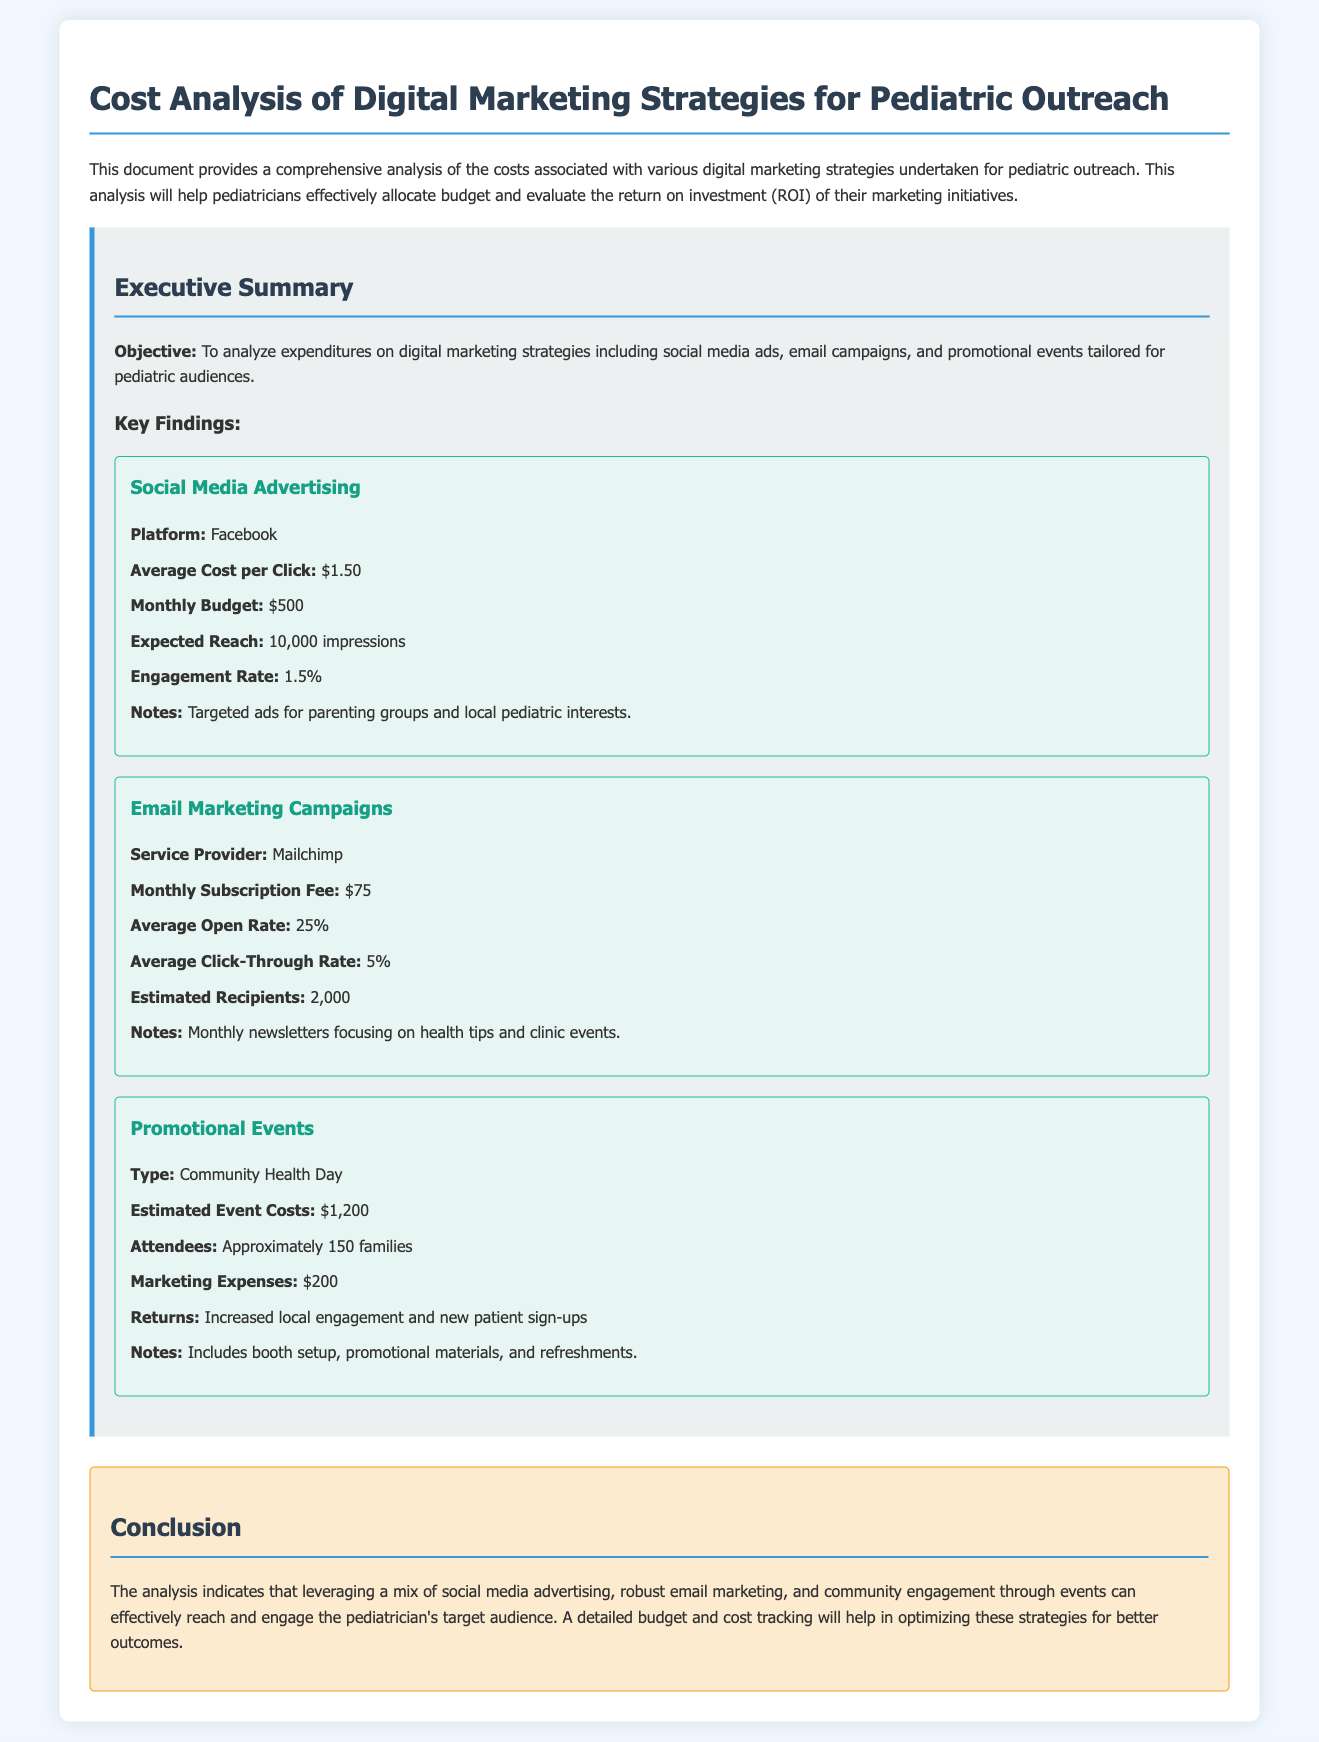What is the average cost per click for social media ads? The average cost per click for social media ads is stated directly under the social media advertising section in the document.
Answer: $1.50 What is the monthly budget allocated for social media advertising? The monthly budget for social media advertising is listed in the social media advertising section which outlines specific financial expenditures.
Answer: $500 What is the monthly subscription fee for the email marketing service? The document specifies the monthly subscription fee for Mailchimp, the chosen email marketing service.
Answer: $75 How many estimated recipients are there for the email campaigns? The estimated recipients for the email marketing campaigns can be found in the email marketing section.
Answer: 2,000 What is the estimated cost for the promotional event? The document highlights the estimated costs associated with the community health day under the promotional events section.
Answer: $1,200 What is the average open rate for email marketing campaigns? The average open rate is provided in the email marketing campaigns section, reflecting engagement statistics.
Answer: 25% What type of event is mentioned for promotional outreach? The document specifies the type of promotional event planned for outreach under the promotional events section.
Answer: Community Health Day What is the engagement rate for social media ads? The engagement rate is listed in the social media advertising section which indicates the performance of the ad campaign.
Answer: 1.5% How many families attended the promotional event? The number of attendees at the community health day is mentioned in the promotional events section, which gives insight into event success.
Answer: Approximately 150 families 